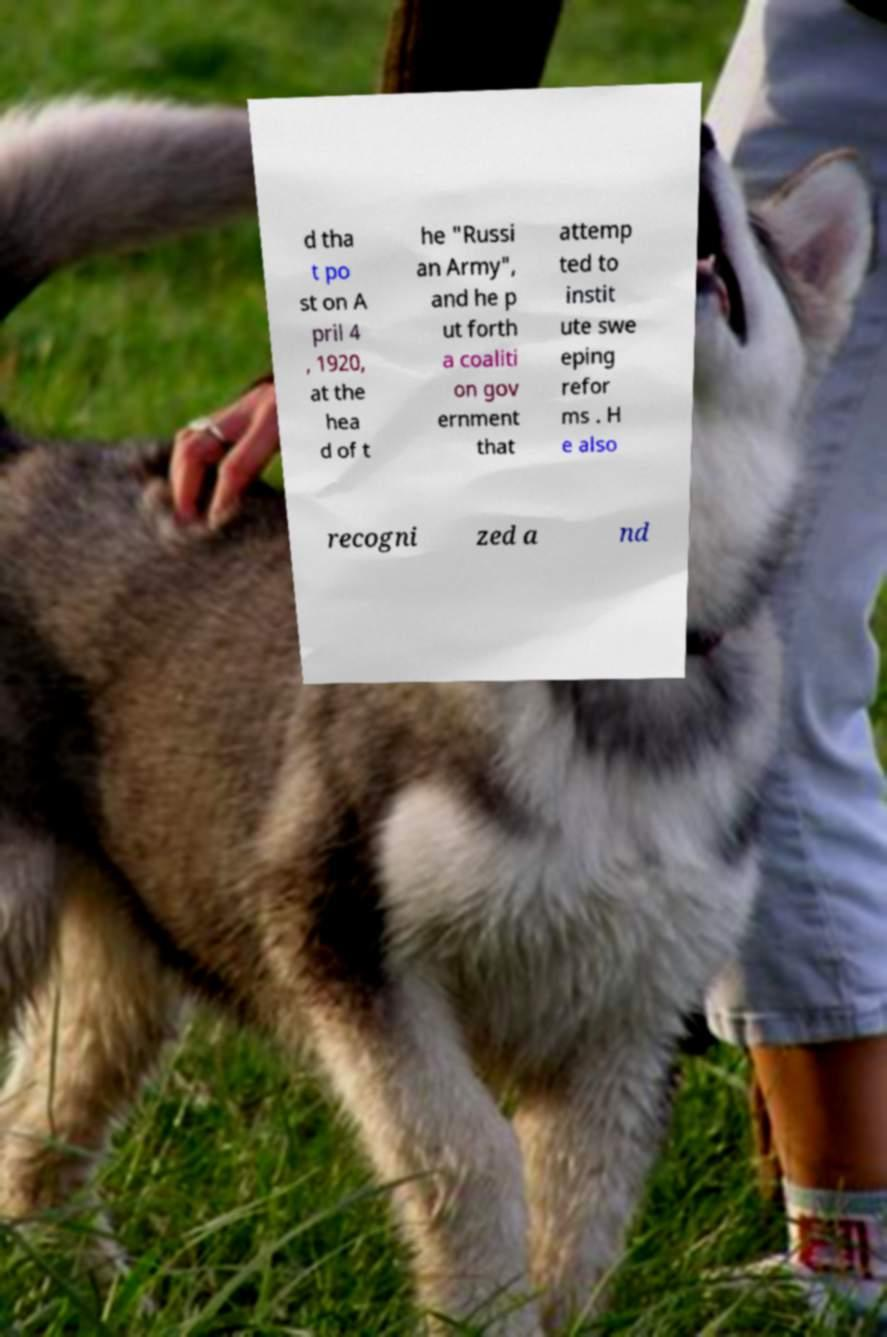What messages or text are displayed in this image? I need them in a readable, typed format. d tha t po st on A pril 4 , 1920, at the hea d of t he "Russi an Army", and he p ut forth a coaliti on gov ernment that attemp ted to instit ute swe eping refor ms . H e also recogni zed a nd 